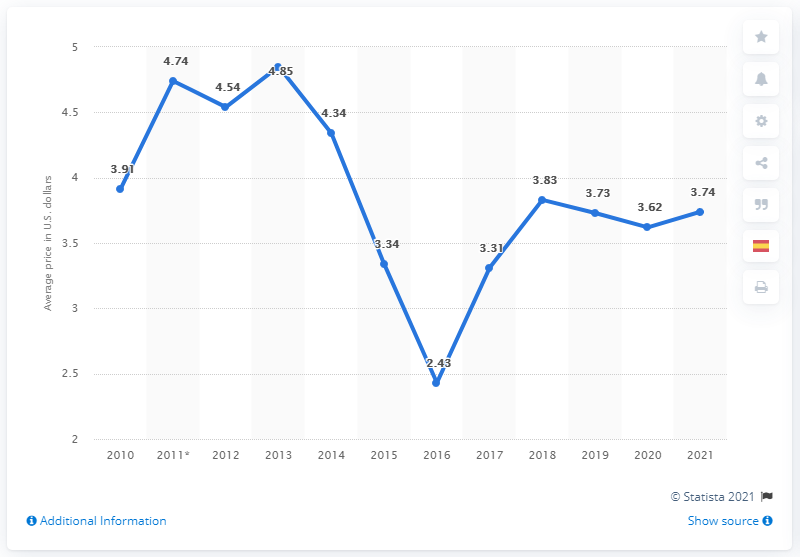List a handful of essential elements in this visual. In January 2021, the average price of a Big Mac burger in Colombia was 3.74. 